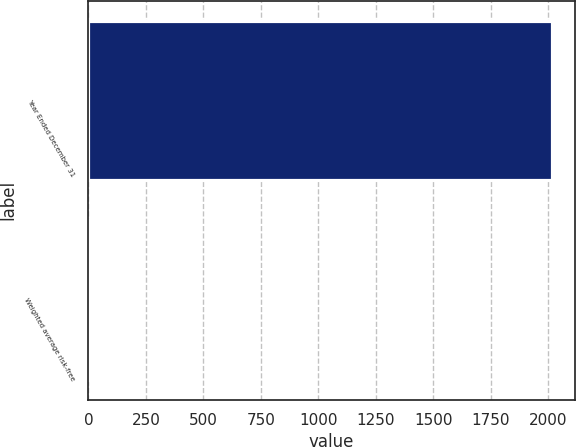<chart> <loc_0><loc_0><loc_500><loc_500><bar_chart><fcel>Year Ended December 31<fcel>Weighted average risk-free<nl><fcel>2015<fcel>1.5<nl></chart> 